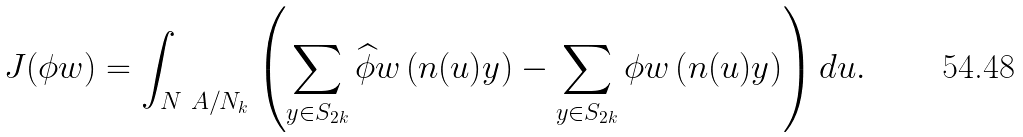Convert formula to latex. <formula><loc_0><loc_0><loc_500><loc_500>J ( \phi w ) = \int _ { N _ { \ } A / N _ { k } } \left ( \sum _ { y \in S _ { 2 k } } \widehat { \phi } w \left ( n ( u ) y \right ) - \sum _ { y \in S _ { 2 k } } \phi w \left ( n ( u ) y \right ) \right ) d u .</formula> 